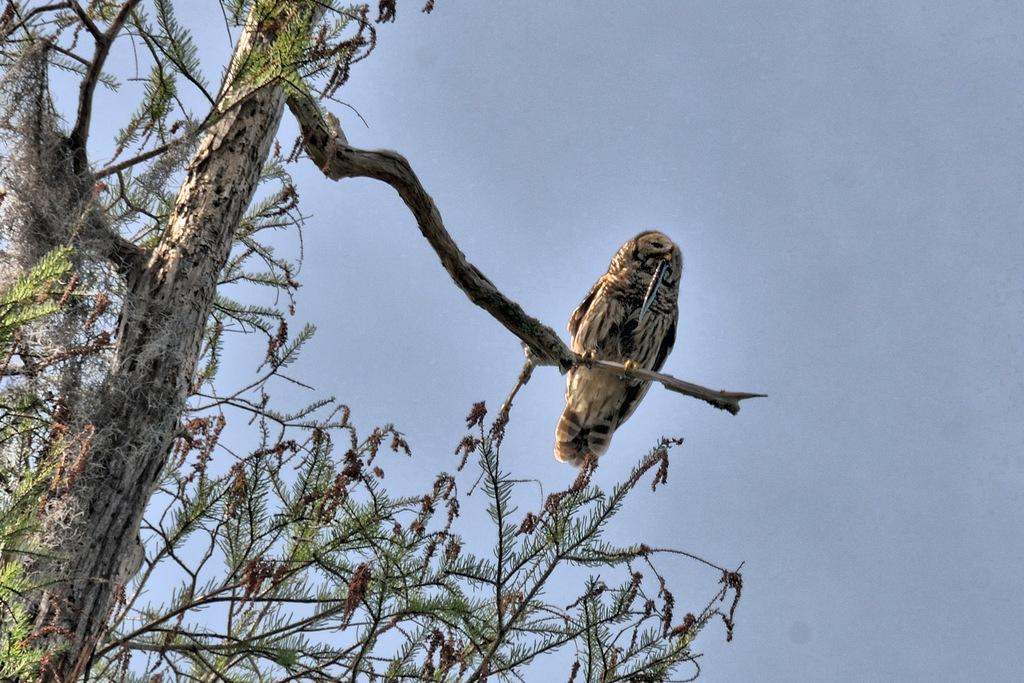What animal is present in the image? There is an owl in the image. Where is the owl located? The owl is on a tree stem. What type of tree can be seen in the image? There is a tree with green leaves in the image. What is visible at the top of the image? The sky is visible at the top of the image. What type of cord is being used by the owl to hang from the tree? There is no cord present in the image; the owl is sitting on a tree stem. How does the owl's wealth affect its ability to fly in the image? The image does not provide any information about the owl's wealth, and wealth does not affect an owl's ability to fly. 